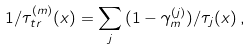Convert formula to latex. <formula><loc_0><loc_0><loc_500><loc_500>1 / \tau ^ { ( m ) } _ { t r } ( x ) = \sum _ { j } \, ( 1 - \gamma _ { m } ^ { ( j ) } ) / { \tau _ { j } ( x ) } \, ,</formula> 